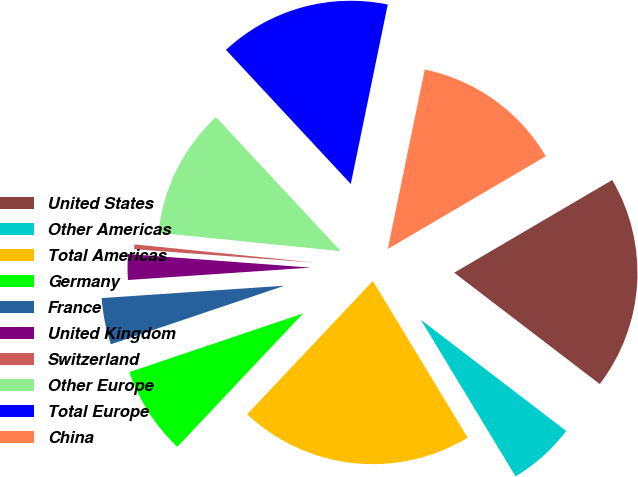Convert chart to OTSL. <chart><loc_0><loc_0><loc_500><loc_500><pie_chart><fcel>United States<fcel>Other Americas<fcel>Total Americas<fcel>Germany<fcel>France<fcel>United Kingdom<fcel>Switzerland<fcel>Other Europe<fcel>Total Europe<fcel>China<nl><fcel>18.84%<fcel>5.95%<fcel>20.69%<fcel>7.79%<fcel>4.1%<fcel>2.26%<fcel>0.42%<fcel>11.47%<fcel>15.16%<fcel>13.32%<nl></chart> 